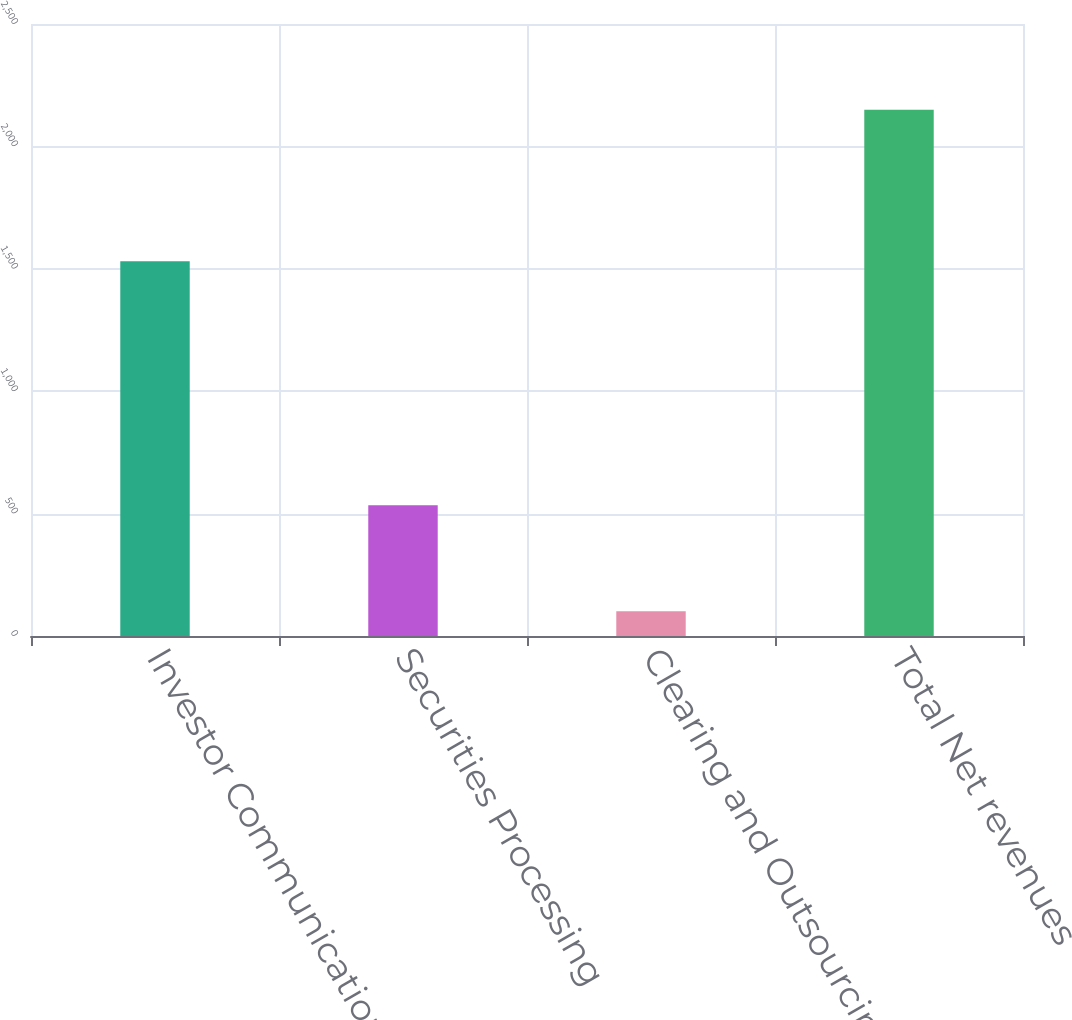Convert chart. <chart><loc_0><loc_0><loc_500><loc_500><bar_chart><fcel>Investor Communication<fcel>Securities Processing<fcel>Clearing and Outsourcing<fcel>Total Net revenues<nl><fcel>1531<fcel>533.8<fcel>101.4<fcel>2149.3<nl></chart> 